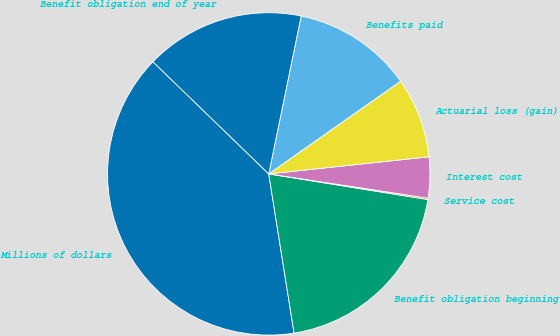Convert chart to OTSL. <chart><loc_0><loc_0><loc_500><loc_500><pie_chart><fcel>Millions of dollars<fcel>Benefit obligation beginning<fcel>Service cost<fcel>Interest cost<fcel>Actuarial loss (gain)<fcel>Benefits paid<fcel>Benefit obligation end of year<nl><fcel>39.75%<fcel>19.94%<fcel>0.14%<fcel>4.1%<fcel>8.06%<fcel>12.02%<fcel>15.98%<nl></chart> 